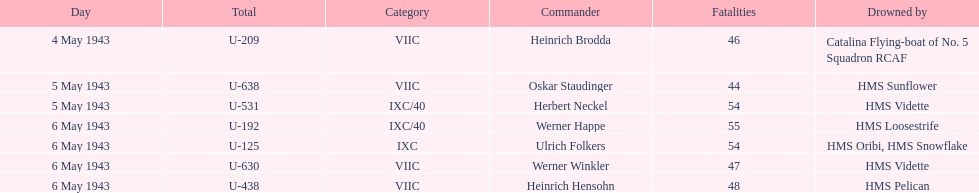Which ship sunk the most u-boats HMS Vidette. 